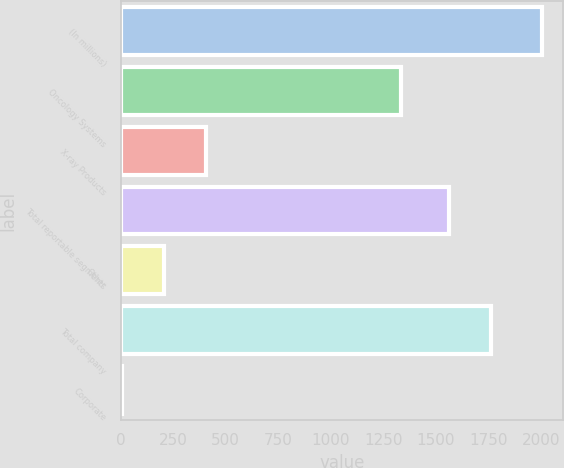<chart> <loc_0><loc_0><loc_500><loc_500><bar_chart><fcel>(In millions)<fcel>Oncology Systems<fcel>X-ray Products<fcel>Total reportable segments<fcel>Other<fcel>Total company<fcel>Corporate<nl><fcel>2006<fcel>1336<fcel>407.6<fcel>1564<fcel>207.8<fcel>1763.8<fcel>8<nl></chart> 